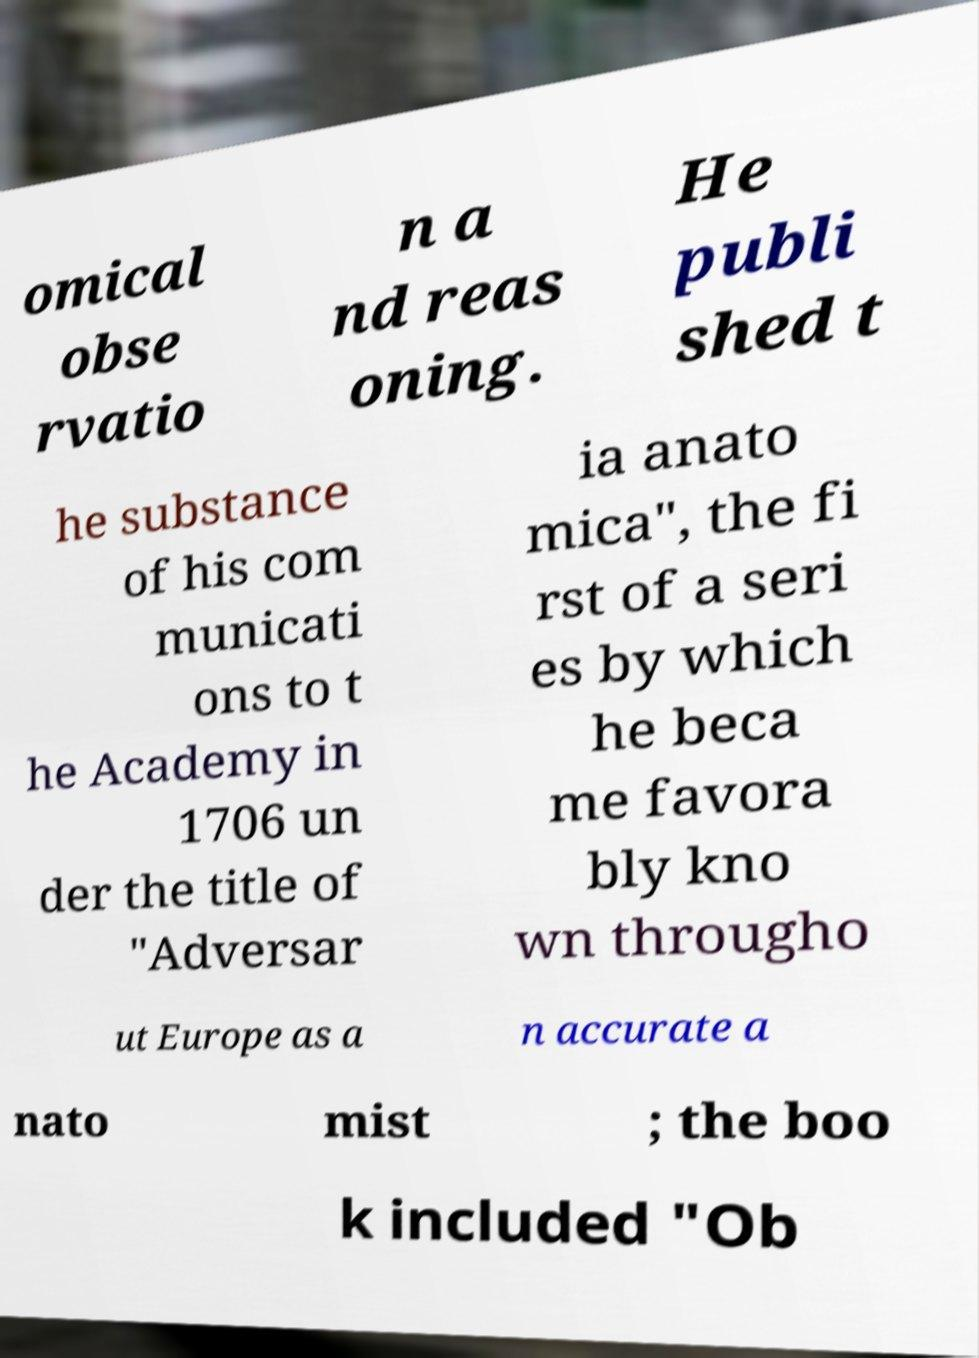For documentation purposes, I need the text within this image transcribed. Could you provide that? omical obse rvatio n a nd reas oning. He publi shed t he substance of his com municati ons to t he Academy in 1706 un der the title of "Adversar ia anato mica", the fi rst of a seri es by which he beca me favora bly kno wn througho ut Europe as a n accurate a nato mist ; the boo k included "Ob 